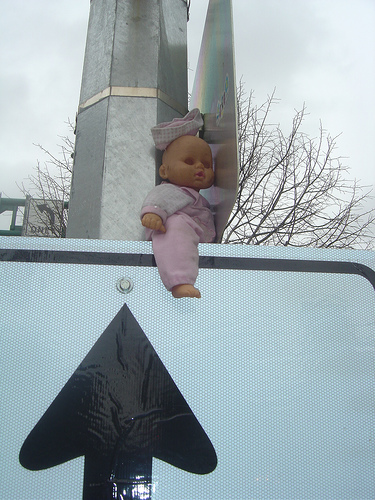<image>
Is the doll leg in the sign? No. The doll leg is not contained within the sign. These objects have a different spatial relationship. 